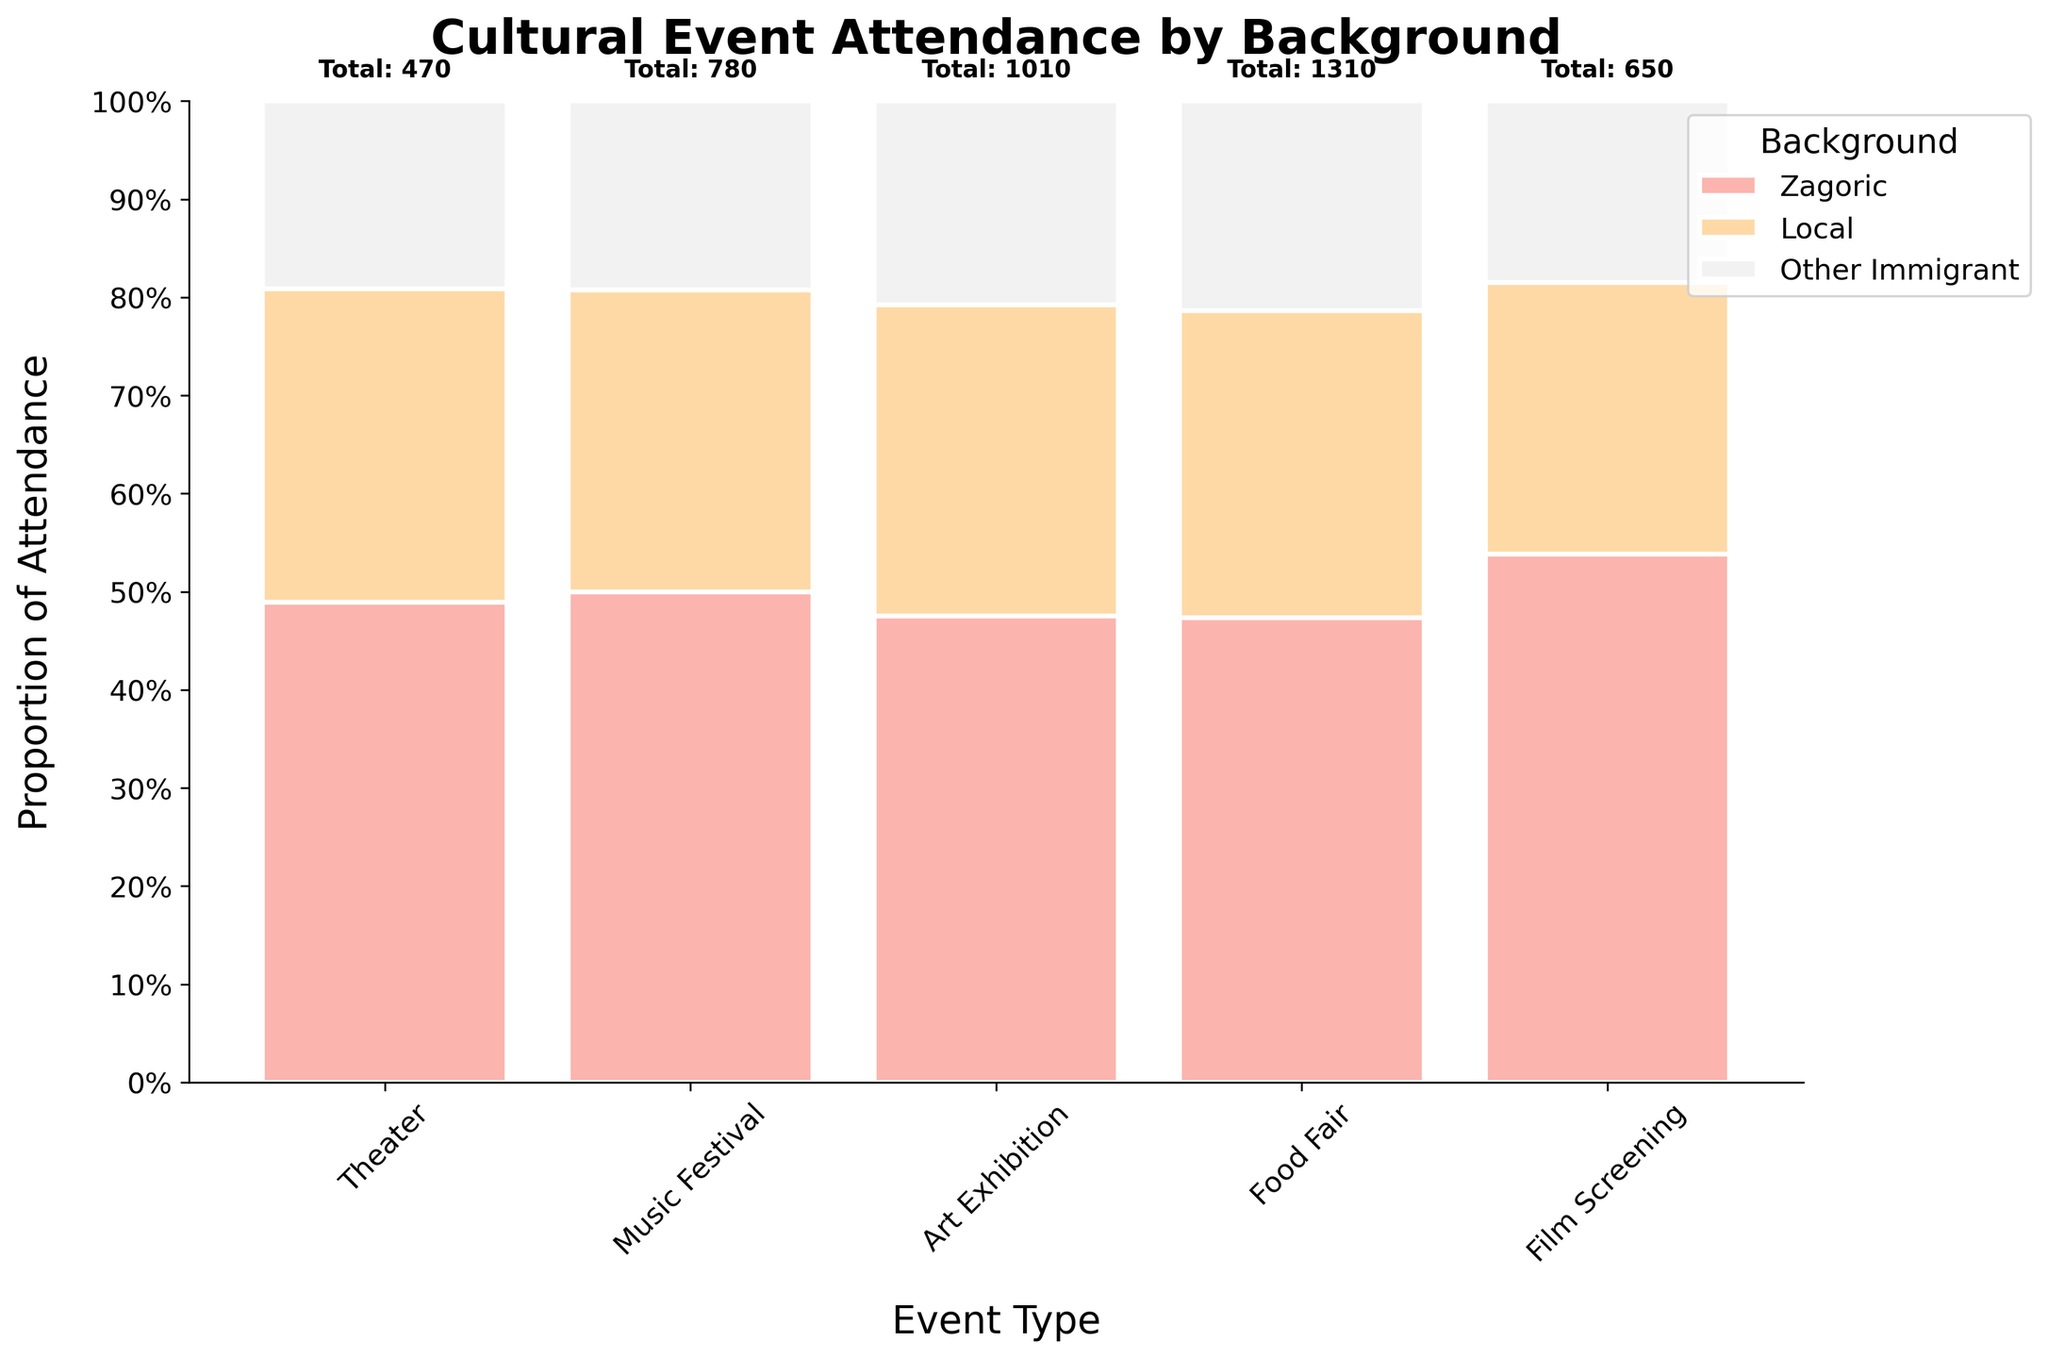What's the title of the plot? The plot's title is typically displayed prominently at the top of the figure, usually in bold. It provides a summary of what the plot represents. In this case, the title is "Cultural Event Attendance by Background."
Answer: Cultural Event Attendance by Background Which group has the highest attendance in a Music Festival? To determine the highest attendance in a Music Festival, check the Music Festival category and compare the proportions of each group. The group with the largest segment will have the highest attendance. Here, the Local group has the highest segment.
Answer: Local What is the total attendance for Theater events? The total attendance number is usually indicated above each event type. For Theater events, the number shown is 650.
Answer: 650 What's the proportion of Zagoric attendees at Food Fairs relative to total Food Fair attendance? Identify the proportion visually for Zagoric attendees in the Food Fair section. Find the segment size and compare it to the total. The proportion is shown as approximately 0.21 or 21% on the y-axis.
Answer: 21% Which background group has the lowest representation at Art Exhibitions? Compare the heights of the segments within the Art Exhibitions category. The group with the smallest segment has the lowest representation. In this case, the Zagoric group has the lowest representation.
Answer: Zagoric How does the proportion of Other Immigrant attendees at Film Screenings compare to Theater events? Look at the heights of the segments for Other Immigrants in both Film Screenings and Theater events. Compare these heights to see the difference. Other Immigrant representation is higher in Film Screenings than in Theater events.
Answer: Higher in Film Screenings What is the combined percentage of Local and Other Immigrant attendees for the Music Festival? Find the proportions for Local and Other Immigrant attendees in the Music Festival category by looking at the segment heights. Add these proportions: roughly 0.62 (Local) + 0.41 (Other Immigrant) = 1.03, but since the total proportion must be 1, you will see some overlapping due to approximation. Actual combined proportion should be checked.
Answer: 100% What trend can you observe about the attendance of Zagoric people across different event types? Visually compare the length of the Zagoric segments across all event types. The attendance is highest in Music Festival, followed by Food Fair and Film Screening, with the lowest in Art Exhibitions. This indicates that Music Festivals attract more Zagoric attendees.
Answer: Music Festival > Food Fair > Film Screening > Art Exhibition Is there any event type where the proportion of Local attendees is below 50%? Check the proportions of Local attendees across all event types visually. See if any segment's height falls below the 50% mark on the y-axis. In all cases, the Local attendees' proportions are above 50%.
Answer: No 